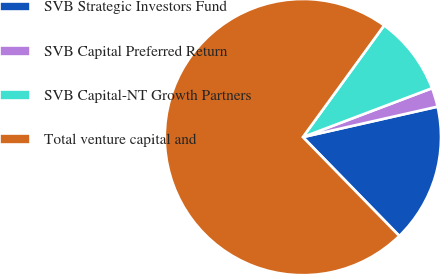Convert chart. <chart><loc_0><loc_0><loc_500><loc_500><pie_chart><fcel>SVB Strategic Investors Fund<fcel>SVB Capital Preferred Return<fcel>SVB Capital-NT Growth Partners<fcel>Total venture capital and<nl><fcel>16.24%<fcel>2.22%<fcel>9.23%<fcel>72.31%<nl></chart> 